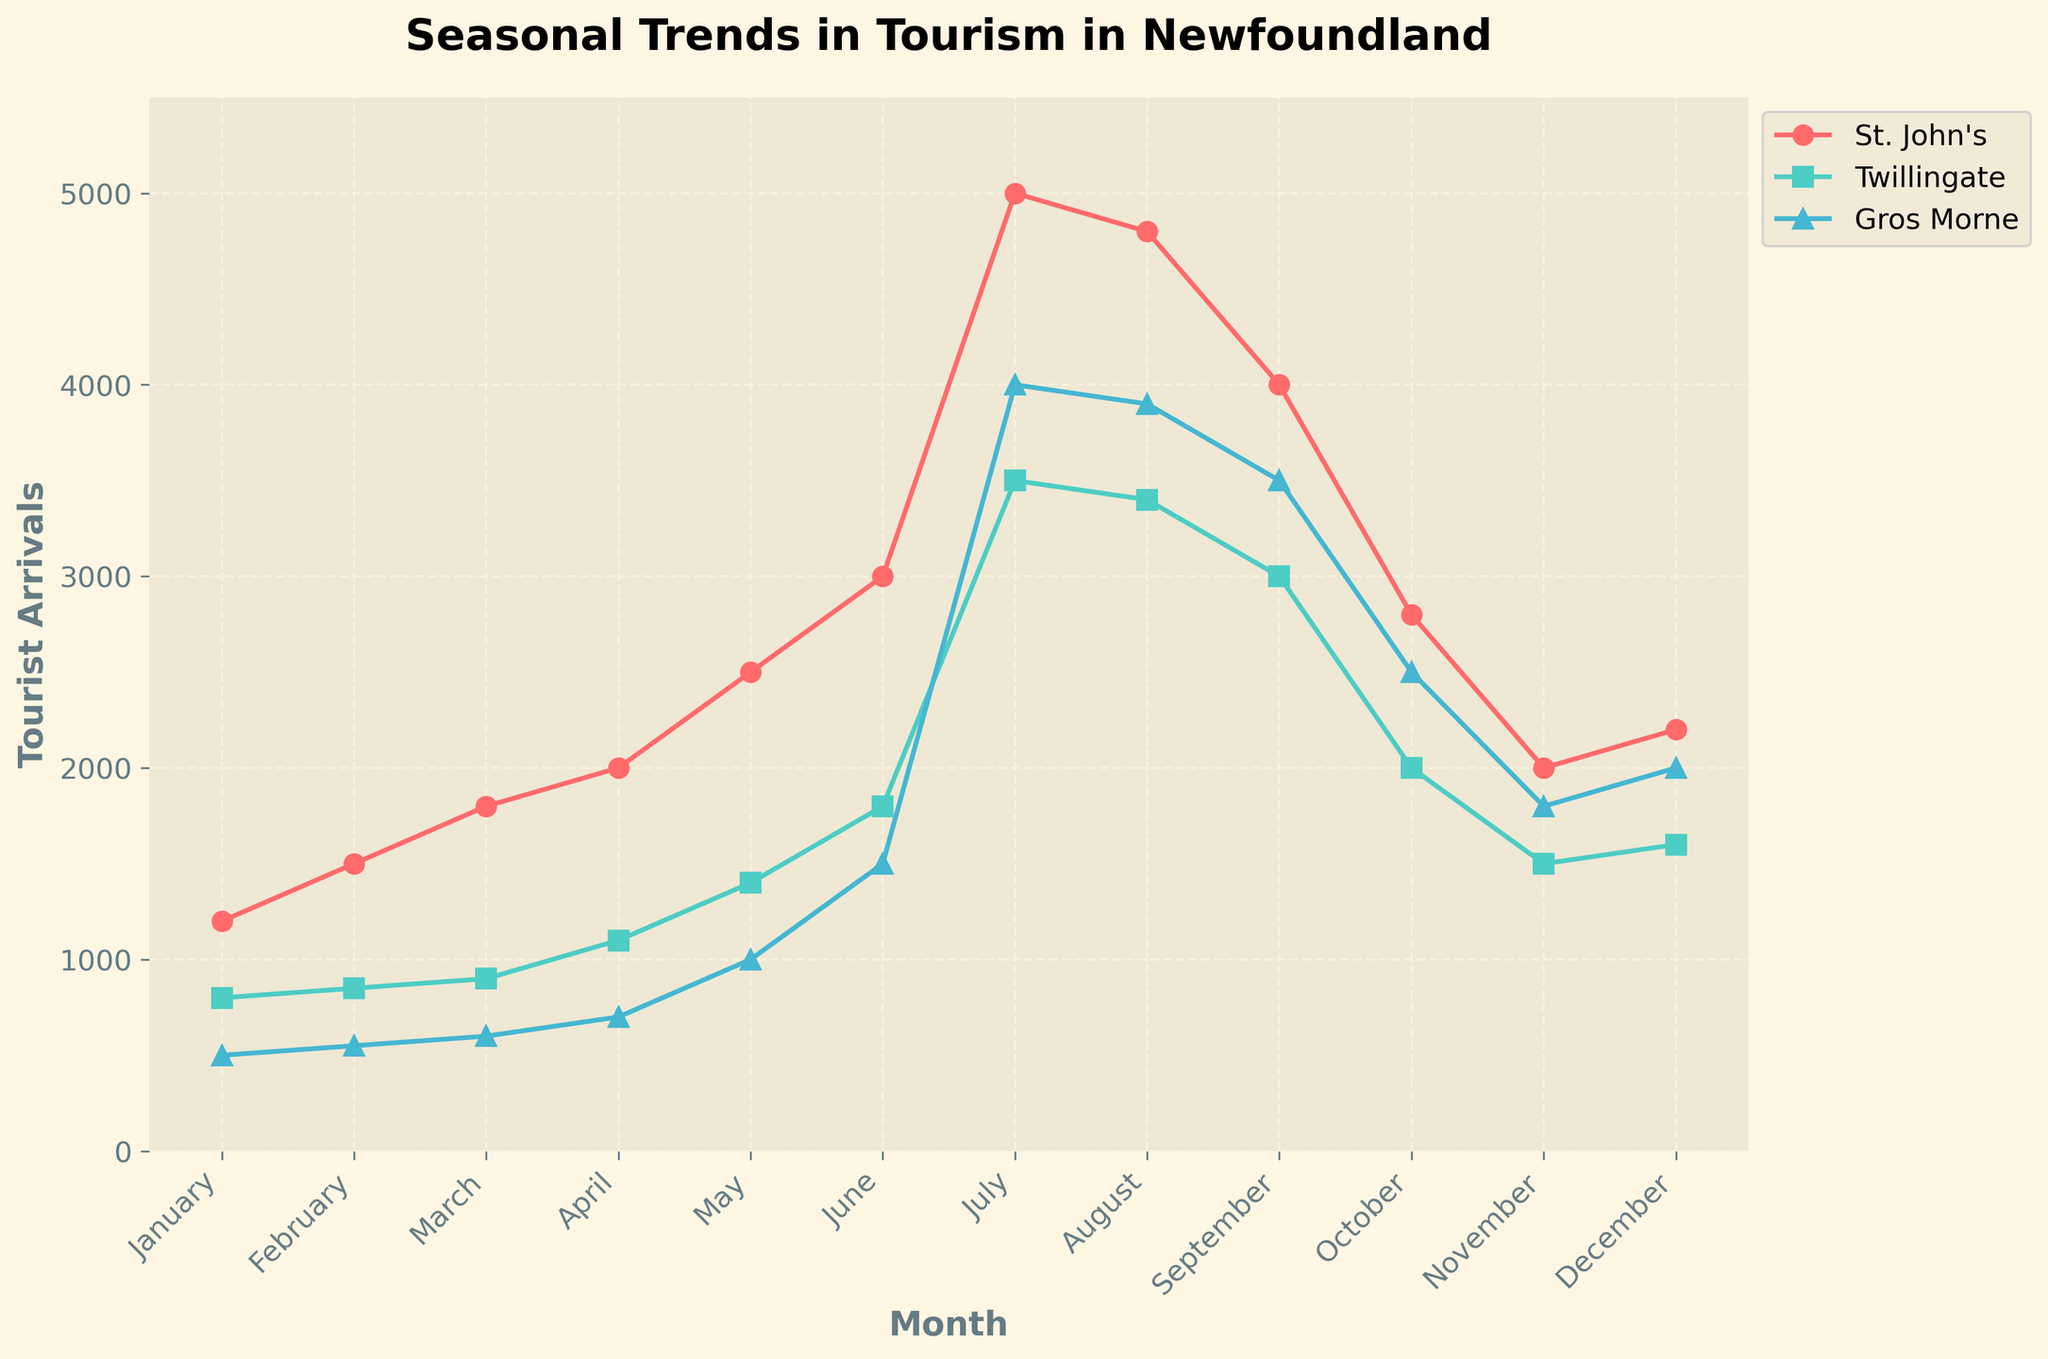What is the title of the plot? The title of the plot is located at the top of the figure. It typically summarizes the main subject of the plot in a brief statement.
Answer: Seasonal Trends in Tourism in Newfoundland What months show the peaks in tourist arrivals for St. John's? By observing the trend line for St. John's on the x-axis (Months) and y-axis (Tourist Arrivals), the highest points can be identified.
Answer: July and August Which city had the lowest tourist arrivals in January? By comparing the plotted values for January for each city, the city with the lowest point on the y-axis (Tourist Arrivals) can be identified.
Answer: Gros Morne Which city has the highest tourist arrivals in July? Identify the highest peak in July by looking at the plotted points for each city in the month of July on the x-axis.
Answer: St. John's What's the difference in tourist arrivals between July and January for Twillingate? Find the data points for Twillingate in both July and January, then subtract the January value from the July value.
Answer: 3500 - 800 = 2700 What is the average tourist arrival for Gros Morne from June to August? Sum the tourist arrivals from June to August for Gros Morne and then divide by the number of months.
Answer: (1500 + 4000 + 3900) / 3 = 3133.33 Compare the tourist arrival trends of Twillingate and St. John's from January to December. What is a noticeable difference? Compare the shape and peaks of the trend lines for Twillingate and St. John's across the months. Notice how their peaks differ in relative positions and magnitude.
Answer: St. John's has higher peaks, especially in July and August During which month do all three cities have the same trend in terms of overall increase or decrease in tourist arrivals? By examining the slopes of all three cities' trend lines month-by-month, the month where all three city's trend lines show either an increase or decrease can be identified.
Answer: July (all have a peak) In which months do tourist arrivals in Gros Morne surpass those in Twillingate? Compare the plotted values of Gros Morne and Twillingate month-by-month to identify when Gros Morne's line is above Twillingate's.
Answer: July and August Which city has the most consistent increase in tourist arrivals from January to July? Assess each city's trend line from January to July for consistent slope/pattern, indicating a steady increase.
Answer: St. John's 